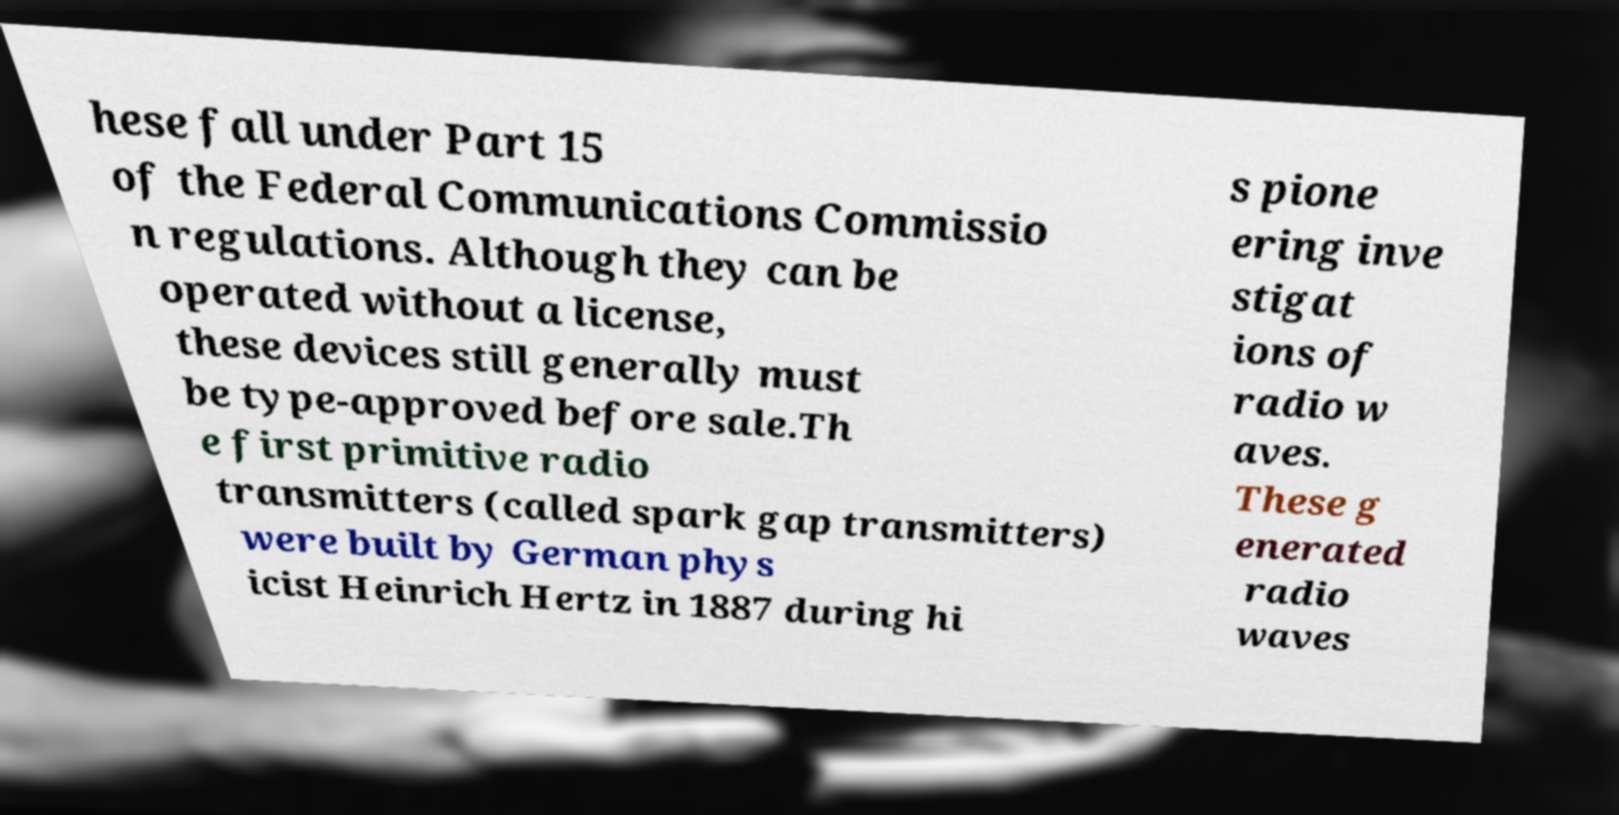What messages or text are displayed in this image? I need them in a readable, typed format. hese fall under Part 15 of the Federal Communications Commissio n regulations. Although they can be operated without a license, these devices still generally must be type-approved before sale.Th e first primitive radio transmitters (called spark gap transmitters) were built by German phys icist Heinrich Hertz in 1887 during hi s pione ering inve stigat ions of radio w aves. These g enerated radio waves 